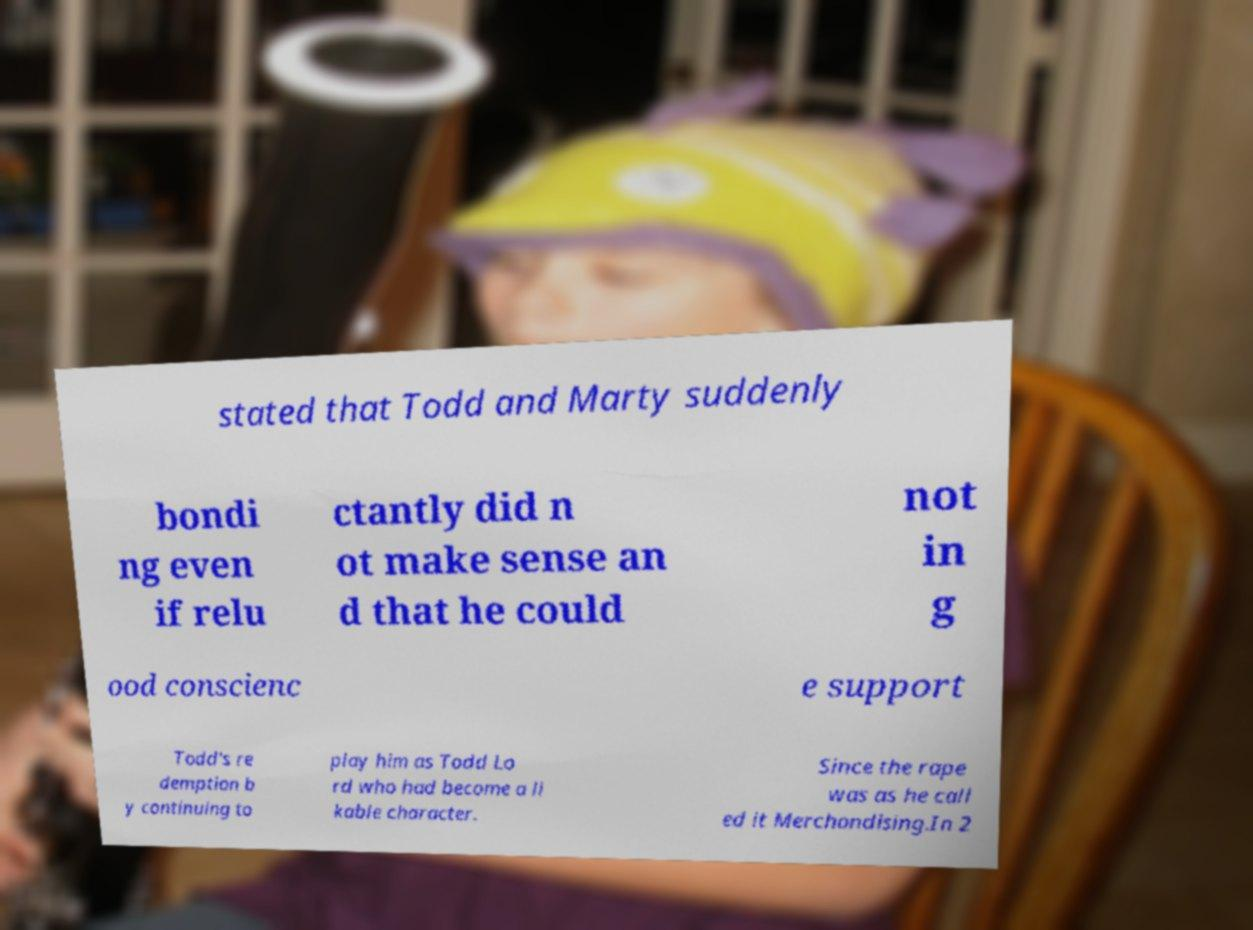What messages or text are displayed in this image? I need them in a readable, typed format. stated that Todd and Marty suddenly bondi ng even if relu ctantly did n ot make sense an d that he could not in g ood conscienc e support Todd's re demption b y continuing to play him as Todd Lo rd who had become a li kable character. Since the rape was as he call ed it Merchandising.In 2 